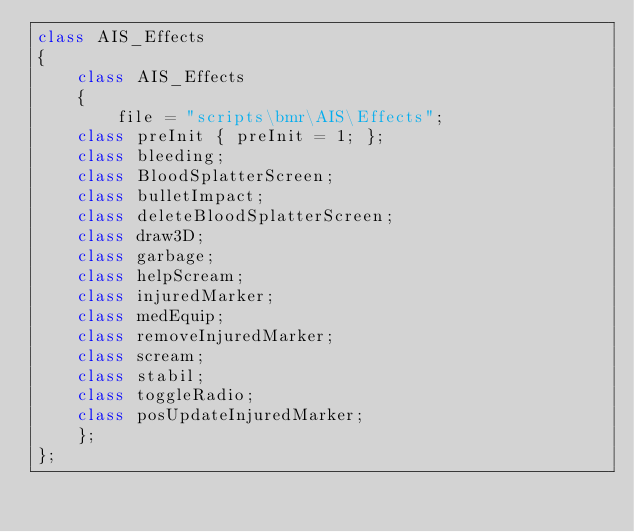<code> <loc_0><loc_0><loc_500><loc_500><_C++_>class AIS_Effects
{
    class AIS_Effects
    {
        file = "scripts\bmr\AIS\Effects";
		class preInit { preInit = 1; };
		class bleeding;
		class BloodSplatterScreen;
		class bulletImpact;
		class deleteBloodSplatterScreen;
		class draw3D;
		class garbage;
		class helpScream;
		class injuredMarker;
		class medEquip;
		class removeInjuredMarker;
		class scream;
		class stabil;
		class toggleRadio;
		class posUpdateInjuredMarker;
    };
};</code> 